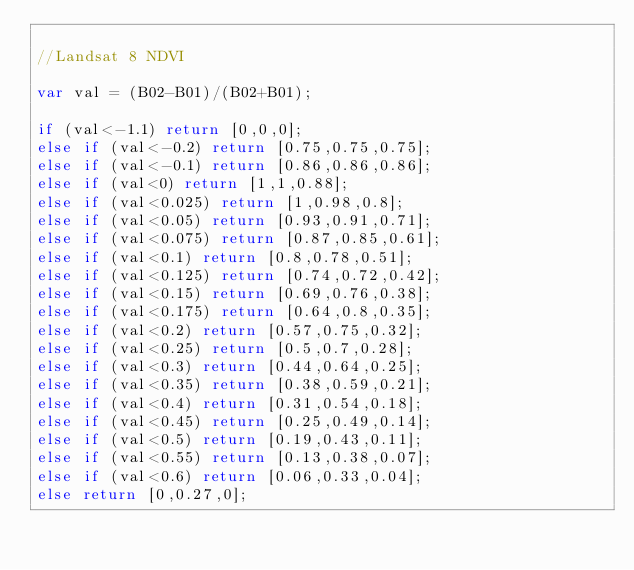Convert code to text. <code><loc_0><loc_0><loc_500><loc_500><_JavaScript_>
//Landsat 8 NDVI

var val = (B02-B01)/(B02+B01);

if (val<-1.1) return [0,0,0];
else if (val<-0.2) return [0.75,0.75,0.75];
else if (val<-0.1) return [0.86,0.86,0.86];
else if (val<0) return [1,1,0.88];
else if (val<0.025) return [1,0.98,0.8];
else if (val<0.05) return [0.93,0.91,0.71];
else if (val<0.075) return [0.87,0.85,0.61];
else if (val<0.1) return [0.8,0.78,0.51];
else if (val<0.125) return [0.74,0.72,0.42];
else if (val<0.15) return [0.69,0.76,0.38];
else if (val<0.175) return [0.64,0.8,0.35];
else if (val<0.2) return [0.57,0.75,0.32];
else if (val<0.25) return [0.5,0.7,0.28];
else if (val<0.3) return [0.44,0.64,0.25];
else if (val<0.35) return [0.38,0.59,0.21];
else if (val<0.4) return [0.31,0.54,0.18];
else if (val<0.45) return [0.25,0.49,0.14];
else if (val<0.5) return [0.19,0.43,0.11];
else if (val<0.55) return [0.13,0.38,0.07];
else if (val<0.6) return [0.06,0.33,0.04];
else return [0,0.27,0];
</code> 